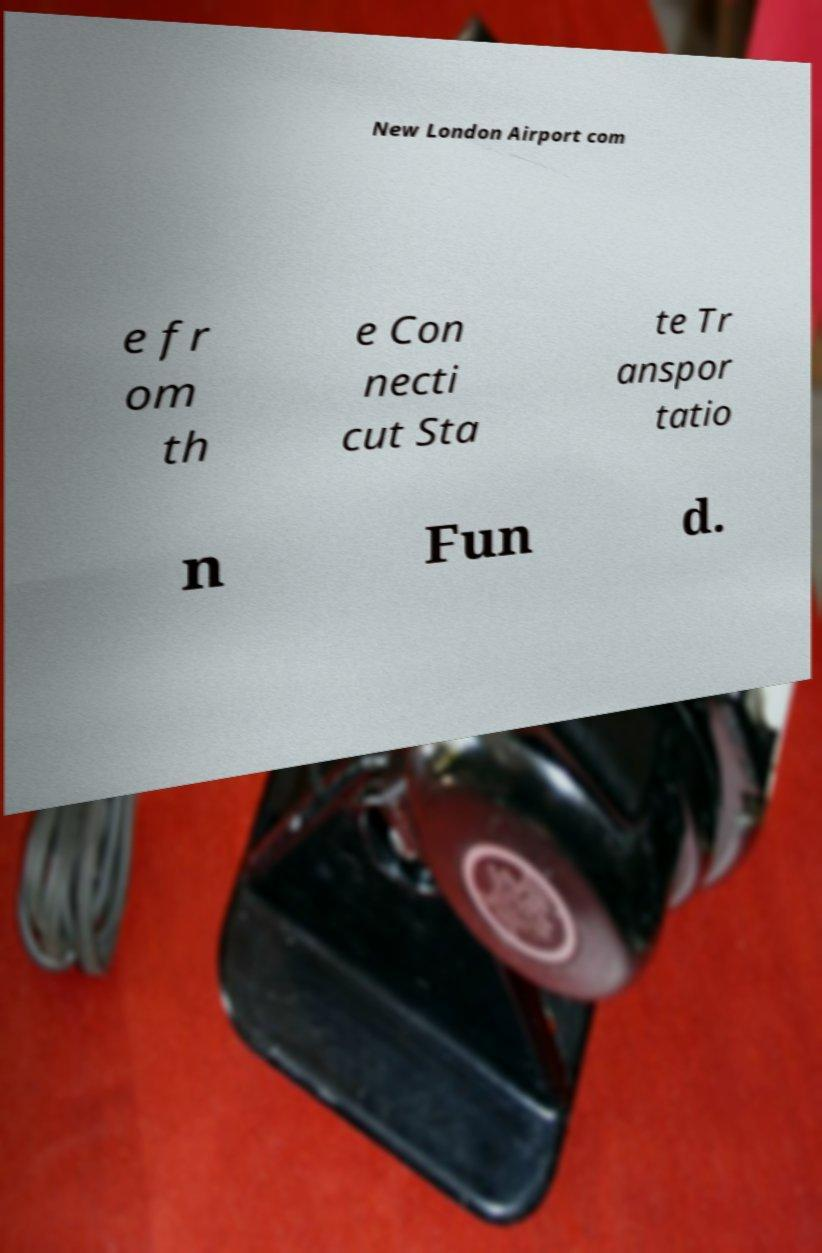Please read and relay the text visible in this image. What does it say? New London Airport com e fr om th e Con necti cut Sta te Tr anspor tatio n Fun d. 